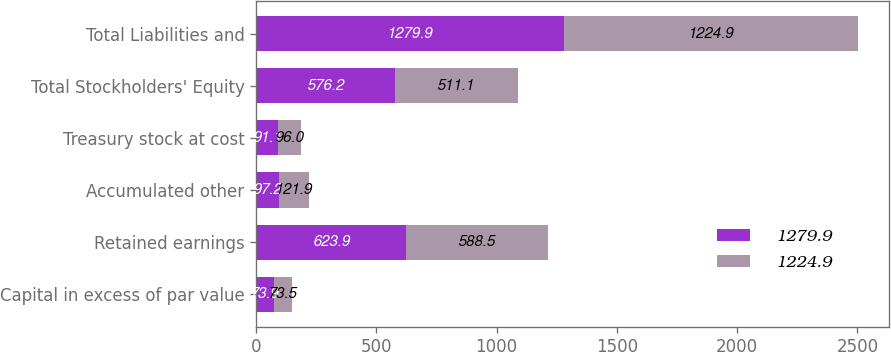Convert chart. <chart><loc_0><loc_0><loc_500><loc_500><stacked_bar_chart><ecel><fcel>Capital in excess of par value<fcel>Retained earnings<fcel>Accumulated other<fcel>Treasury stock at cost<fcel>Total Stockholders' Equity<fcel>Total Liabilities and<nl><fcel>1279.9<fcel>73.9<fcel>623.9<fcel>97.2<fcel>91.1<fcel>576.2<fcel>1279.9<nl><fcel>1224.9<fcel>73.5<fcel>588.5<fcel>121.9<fcel>96<fcel>511.1<fcel>1224.9<nl></chart> 